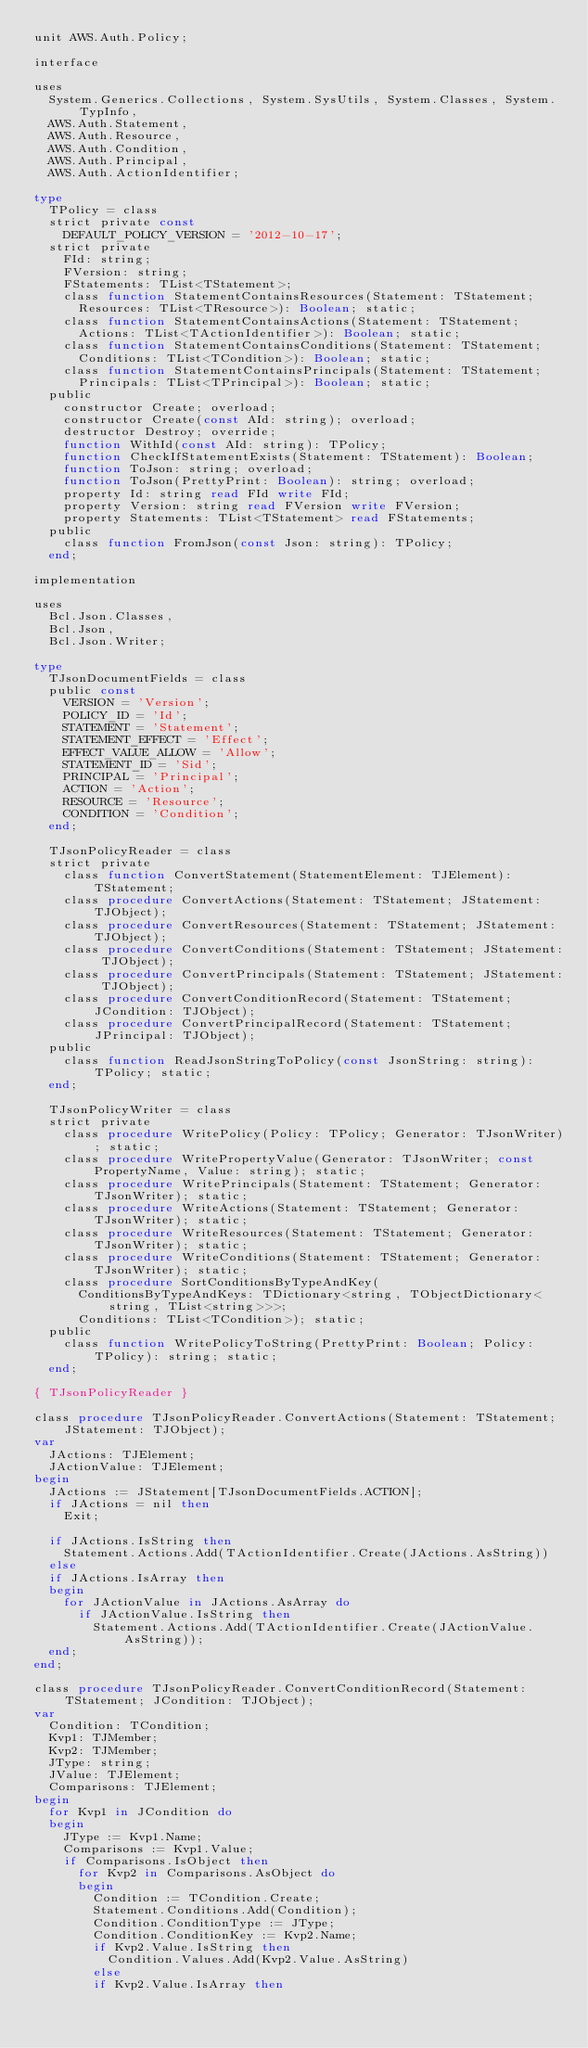Convert code to text. <code><loc_0><loc_0><loc_500><loc_500><_Pascal_>unit AWS.Auth.Policy;

interface

uses
  System.Generics.Collections, System.SysUtils, System.Classes, System.TypInfo,
  AWS.Auth.Statement,
  AWS.Auth.Resource,
  AWS.Auth.Condition,
  AWS.Auth.Principal,
  AWS.Auth.ActionIdentifier;

type
  TPolicy = class
  strict private const
    DEFAULT_POLICY_VERSION = '2012-10-17';
  strict private
    FId: string;
    FVersion: string;
    FStatements: TList<TStatement>;
    class function StatementContainsResources(Statement: TStatement;
      Resources: TList<TResource>): Boolean; static;
    class function StatementContainsActions(Statement: TStatement;
      Actions: TList<TActionIdentifier>): Boolean; static;
    class function StatementContainsConditions(Statement: TStatement;
      Conditions: TList<TCondition>): Boolean; static;
    class function StatementContainsPrincipals(Statement: TStatement;
      Principals: TList<TPrincipal>): Boolean; static;
  public
    constructor Create; overload;
    constructor Create(const AId: string); overload;
    destructor Destroy; override;
    function WithId(const AId: string): TPolicy;
    function CheckIfStatementExists(Statement: TStatement): Boolean;
    function ToJson: string; overload;
    function ToJson(PrettyPrint: Boolean): string; overload;
    property Id: string read FId write FId;
    property Version: string read FVersion write FVersion;
    property Statements: TList<TStatement> read FStatements;
  public
    class function FromJson(const Json: string): TPolicy;
  end;

implementation

uses
  Bcl.Json.Classes,
  Bcl.Json,
  Bcl.Json.Writer;

type
  TJsonDocumentFields = class
  public const
    VERSION = 'Version';
    POLICY_ID = 'Id';
    STATEMENT = 'Statement';
    STATEMENT_EFFECT = 'Effect';
    EFFECT_VALUE_ALLOW = 'Allow';
    STATEMENT_ID = 'Sid';
    PRINCIPAL = 'Principal';
    ACTION = 'Action';
    RESOURCE = 'Resource';
    CONDITION = 'Condition';
  end;

  TJsonPolicyReader = class
  strict private
    class function ConvertStatement(StatementElement: TJElement): TStatement;
    class procedure ConvertActions(Statement: TStatement; JStatement: TJObject);
    class procedure ConvertResources(Statement: TStatement; JStatement: TJObject);
    class procedure ConvertConditions(Statement: TStatement; JStatement: TJObject);
    class procedure ConvertPrincipals(Statement: TStatement; JStatement: TJObject);
    class procedure ConvertConditionRecord(Statement: TStatement; JCondition: TJObject);
    class procedure ConvertPrincipalRecord(Statement: TStatement; JPrincipal: TJObject);
  public
    class function ReadJsonStringToPolicy(const JsonString: string): TPolicy; static;
  end;

  TJsonPolicyWriter = class
  strict private
    class procedure WritePolicy(Policy: TPolicy; Generator: TJsonWriter); static;
    class procedure WritePropertyValue(Generator: TJsonWriter; const PropertyName, Value: string); static;
    class procedure WritePrincipals(Statement: TStatement; Generator: TJsonWriter); static;
    class procedure WriteActions(Statement: TStatement; Generator: TJsonWriter); static;
    class procedure WriteResources(Statement: TStatement; Generator: TJsonWriter); static;
    class procedure WriteConditions(Statement: TStatement; Generator: TJsonWriter); static;
    class procedure SortConditionsByTypeAndKey(
      ConditionsByTypeAndKeys: TDictionary<string, TObjectDictionary<string, TList<string>>>;
      Conditions: TList<TCondition>); static;
  public
    class function WritePolicyToString(PrettyPrint: Boolean; Policy: TPolicy): string; static;
  end;

{ TJsonPolicyReader }

class procedure TJsonPolicyReader.ConvertActions(Statement: TStatement; JStatement: TJObject);
var
  JActions: TJElement;
  JActionValue: TJElement;
begin
  JActions := JStatement[TJsonDocumentFields.ACTION];
  if JActions = nil then
    Exit;

  if JActions.IsString then
    Statement.Actions.Add(TActionIdentifier.Create(JActions.AsString))
  else
  if JActions.IsArray then
  begin
    for JActionValue in JActions.AsArray do
      if JActionValue.IsString then
        Statement.Actions.Add(TActionIdentifier.Create(JActionValue.AsString));
  end;
end;

class procedure TJsonPolicyReader.ConvertConditionRecord(Statement: TStatement; JCondition: TJObject);
var
  Condition: TCondition;
  Kvp1: TJMember;
  Kvp2: TJMember;
  JType: string;
  JValue: TJElement;
  Comparisons: TJElement;
begin
  for Kvp1 in JCondition do
  begin
    JType := Kvp1.Name;
    Comparisons := Kvp1.Value;
    if Comparisons.IsObject then
      for Kvp2 in Comparisons.AsObject do
      begin
        Condition := TCondition.Create;
        Statement.Conditions.Add(Condition);
        Condition.ConditionType := JType;
        Condition.ConditionKey := Kvp2.Name;
        if Kvp2.Value.IsString then
          Condition.Values.Add(Kvp2.Value.AsString)
        else
        if Kvp2.Value.IsArray then</code> 